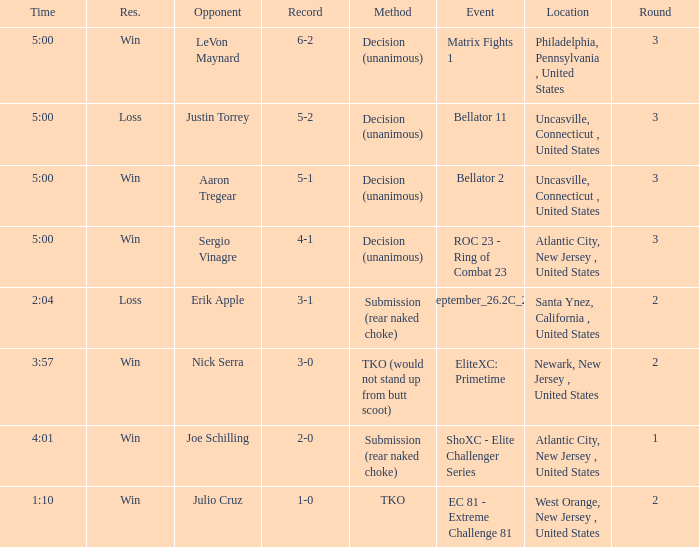Who was the opponent when there was a TKO method? Julio Cruz. 